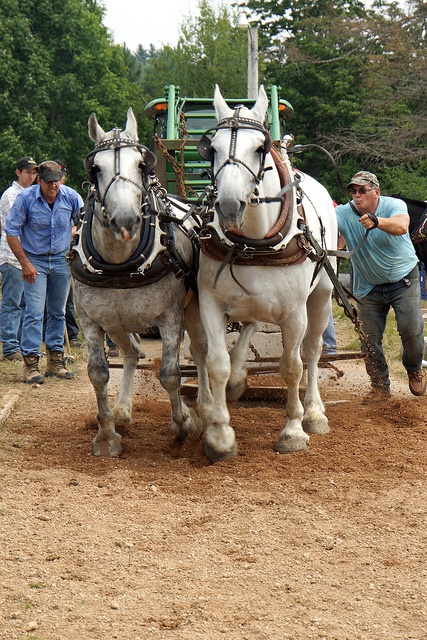Describe the objects in this image and their specific colors. I can see horse in darkgreen, white, darkgray, gray, and black tones, horse in darkgreen, black, gray, and maroon tones, people in darkgreen, black, gray, and maroon tones, people in darkgreen, gray, black, and navy tones, and people in darkgreen, gray, black, blue, and lightgray tones in this image. 